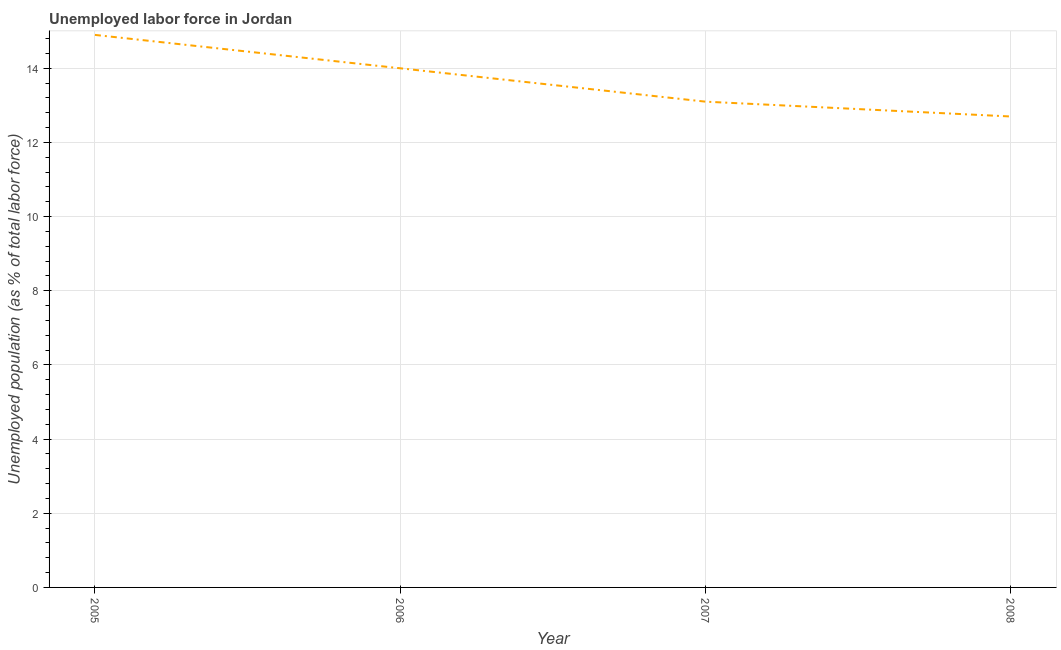What is the total unemployed population in 2007?
Offer a very short reply. 13.1. Across all years, what is the maximum total unemployed population?
Offer a very short reply. 14.9. Across all years, what is the minimum total unemployed population?
Provide a succinct answer. 12.7. In which year was the total unemployed population maximum?
Your response must be concise. 2005. What is the sum of the total unemployed population?
Give a very brief answer. 54.7. What is the difference between the total unemployed population in 2006 and 2008?
Provide a short and direct response. 1.3. What is the average total unemployed population per year?
Offer a terse response. 13.67. What is the median total unemployed population?
Keep it short and to the point. 13.55. Do a majority of the years between 2005 and 2008 (inclusive) have total unemployed population greater than 3.6 %?
Your answer should be compact. Yes. What is the ratio of the total unemployed population in 2007 to that in 2008?
Your answer should be compact. 1.03. What is the difference between the highest and the second highest total unemployed population?
Your answer should be compact. 0.9. What is the difference between the highest and the lowest total unemployed population?
Ensure brevity in your answer.  2.2. How many years are there in the graph?
Ensure brevity in your answer.  4. Are the values on the major ticks of Y-axis written in scientific E-notation?
Give a very brief answer. No. What is the title of the graph?
Ensure brevity in your answer.  Unemployed labor force in Jordan. What is the label or title of the Y-axis?
Keep it short and to the point. Unemployed population (as % of total labor force). What is the Unemployed population (as % of total labor force) in 2005?
Your answer should be compact. 14.9. What is the Unemployed population (as % of total labor force) in 2007?
Offer a very short reply. 13.1. What is the Unemployed population (as % of total labor force) in 2008?
Offer a very short reply. 12.7. What is the difference between the Unemployed population (as % of total labor force) in 2005 and 2006?
Offer a very short reply. 0.9. What is the difference between the Unemployed population (as % of total labor force) in 2005 and 2007?
Your response must be concise. 1.8. What is the difference between the Unemployed population (as % of total labor force) in 2005 and 2008?
Offer a very short reply. 2.2. What is the difference between the Unemployed population (as % of total labor force) in 2006 and 2008?
Provide a succinct answer. 1.3. What is the ratio of the Unemployed population (as % of total labor force) in 2005 to that in 2006?
Make the answer very short. 1.06. What is the ratio of the Unemployed population (as % of total labor force) in 2005 to that in 2007?
Ensure brevity in your answer.  1.14. What is the ratio of the Unemployed population (as % of total labor force) in 2005 to that in 2008?
Ensure brevity in your answer.  1.17. What is the ratio of the Unemployed population (as % of total labor force) in 2006 to that in 2007?
Your answer should be very brief. 1.07. What is the ratio of the Unemployed population (as % of total labor force) in 2006 to that in 2008?
Offer a very short reply. 1.1. What is the ratio of the Unemployed population (as % of total labor force) in 2007 to that in 2008?
Give a very brief answer. 1.03. 